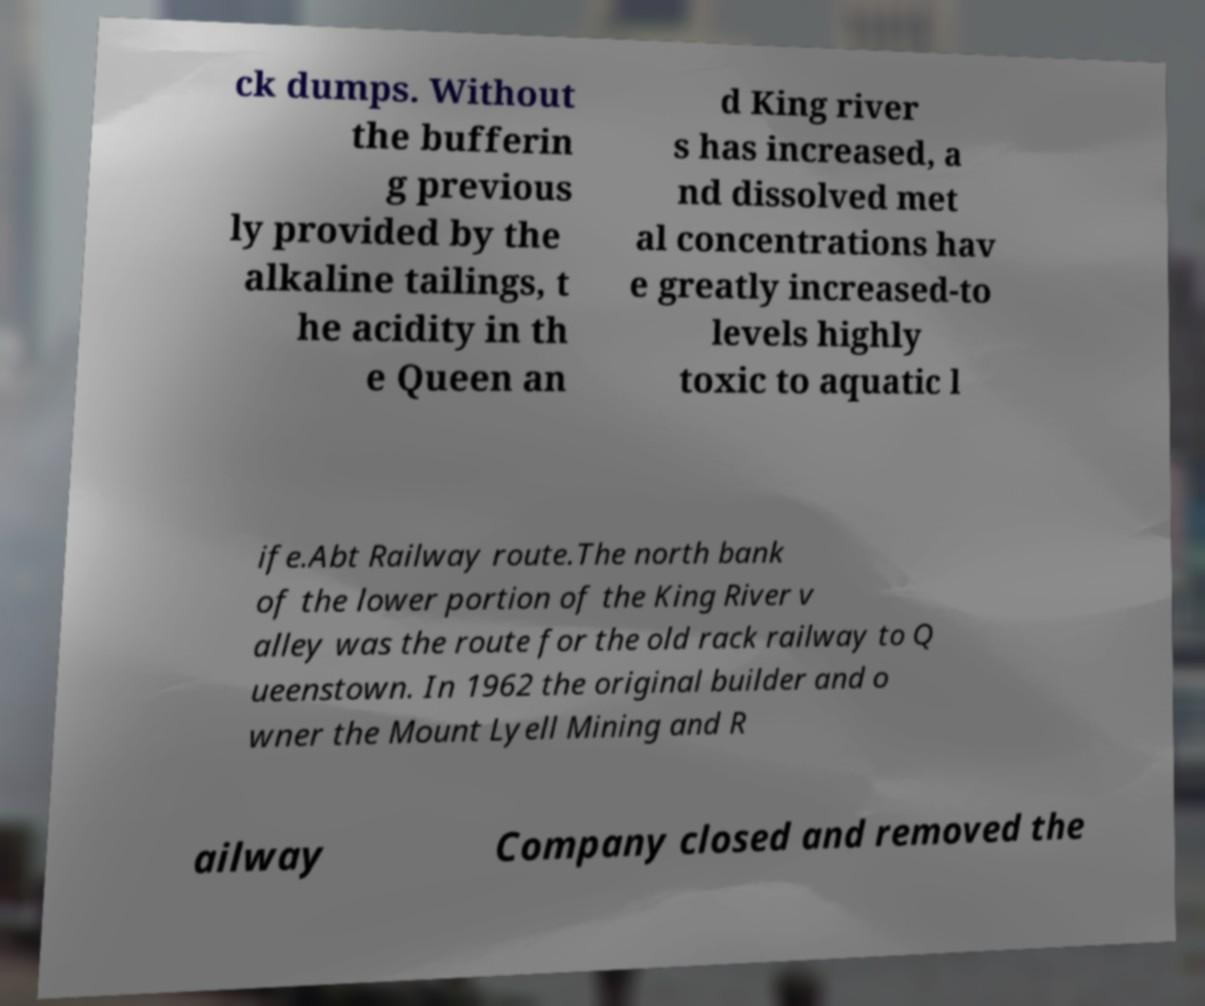There's text embedded in this image that I need extracted. Can you transcribe it verbatim? ck dumps. Without the bufferin g previous ly provided by the alkaline tailings, t he acidity in th e Queen an d King river s has increased, a nd dissolved met al concentrations hav e greatly increased-to levels highly toxic to aquatic l ife.Abt Railway route.The north bank of the lower portion of the King River v alley was the route for the old rack railway to Q ueenstown. In 1962 the original builder and o wner the Mount Lyell Mining and R ailway Company closed and removed the 